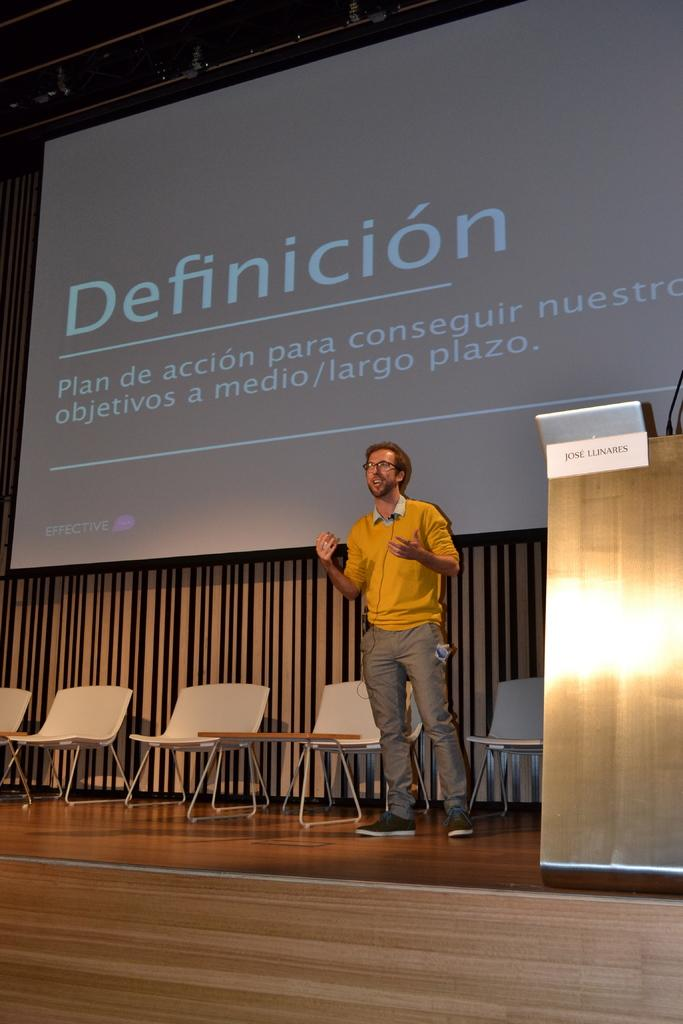Where was the image taken? The image was taken on a stage. What can be seen in the middle of the stage? There are chairs and a person standing in the middle of the stage. What is located on the right side of the stage? There is a podium on the right side of the stage. What is in the middle of the stage besides the chairs and person? There is a screen in the middle of the stage. What type of drum can be heard playing in the image? There is no drum present in the image, and therefore no sound can be heard. 